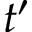<formula> <loc_0><loc_0><loc_500><loc_500>t ^ { \prime }</formula> 